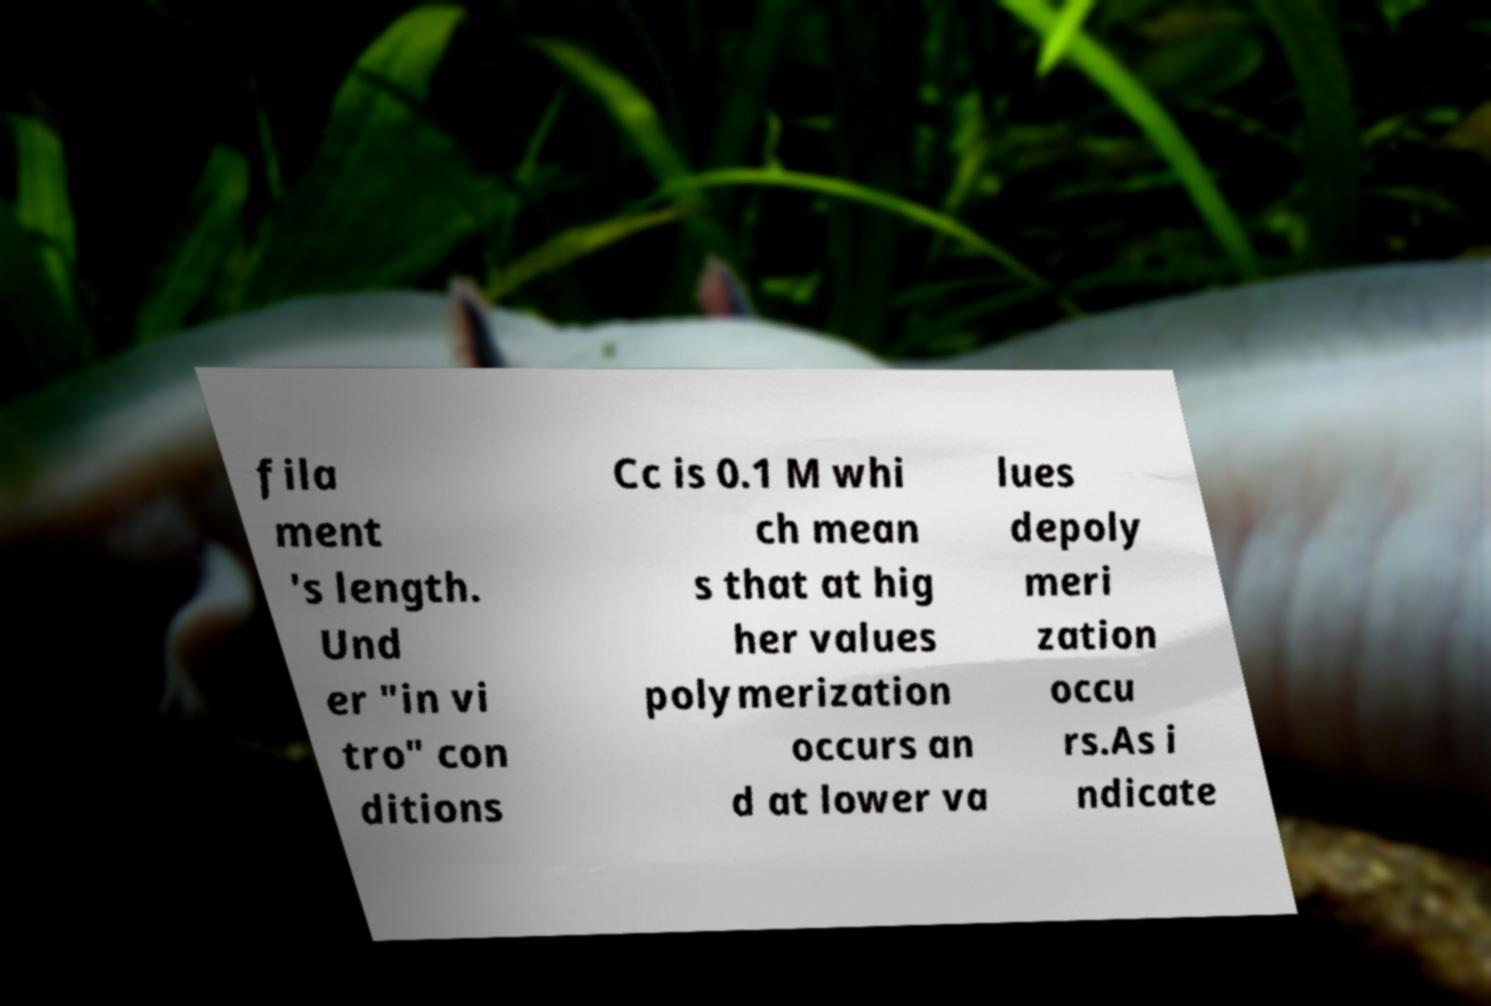I need the written content from this picture converted into text. Can you do that? fila ment 's length. Und er "in vi tro" con ditions Cc is 0.1 M whi ch mean s that at hig her values polymerization occurs an d at lower va lues depoly meri zation occu rs.As i ndicate 